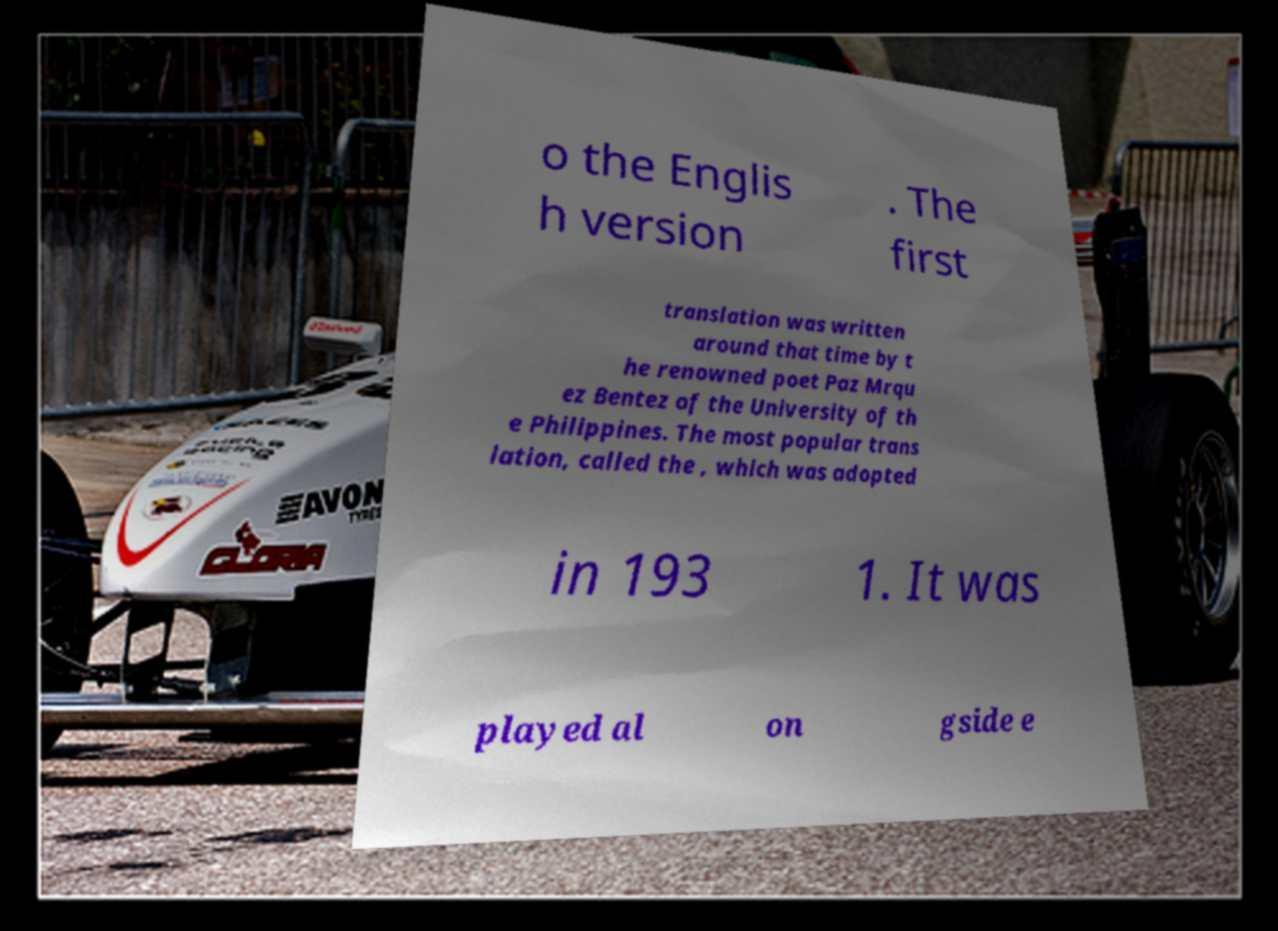What messages or text are displayed in this image? I need them in a readable, typed format. o the Englis h version . The first translation was written around that time by t he renowned poet Paz Mrqu ez Bentez of the University of th e Philippines. The most popular trans lation, called the , which was adopted in 193 1. It was played al on gside e 